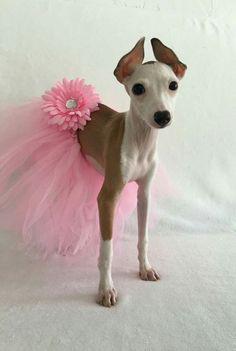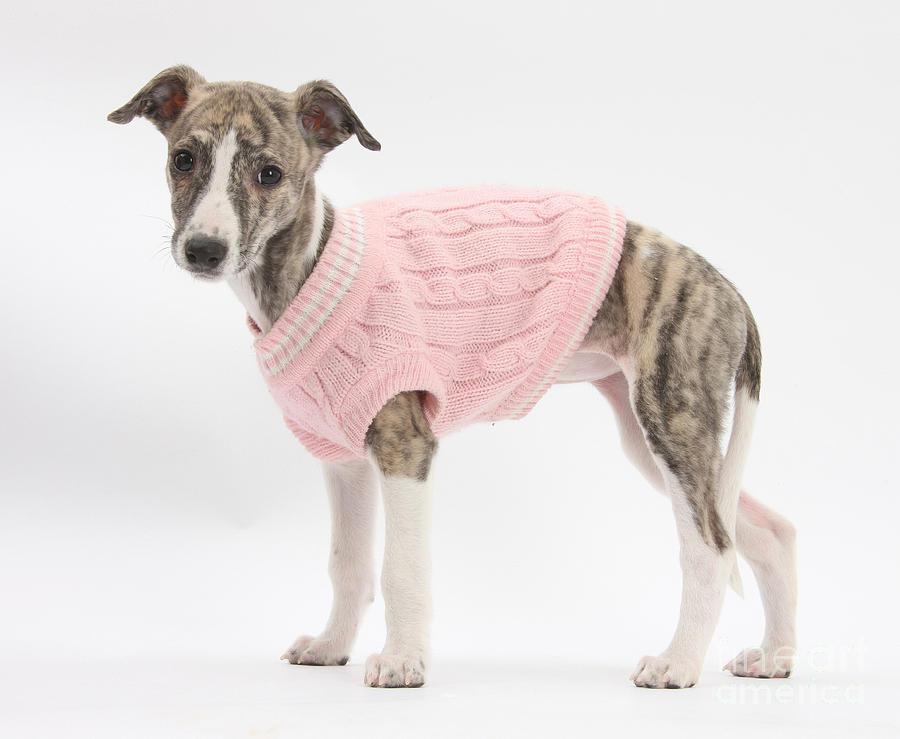The first image is the image on the left, the second image is the image on the right. Given the left and right images, does the statement "At least two dogs have gray faces." hold true? Answer yes or no. No. The first image is the image on the left, the second image is the image on the right. For the images shown, is this caption "there is a solid gray dog with no white patches in one of the images." true? Answer yes or no. No. 